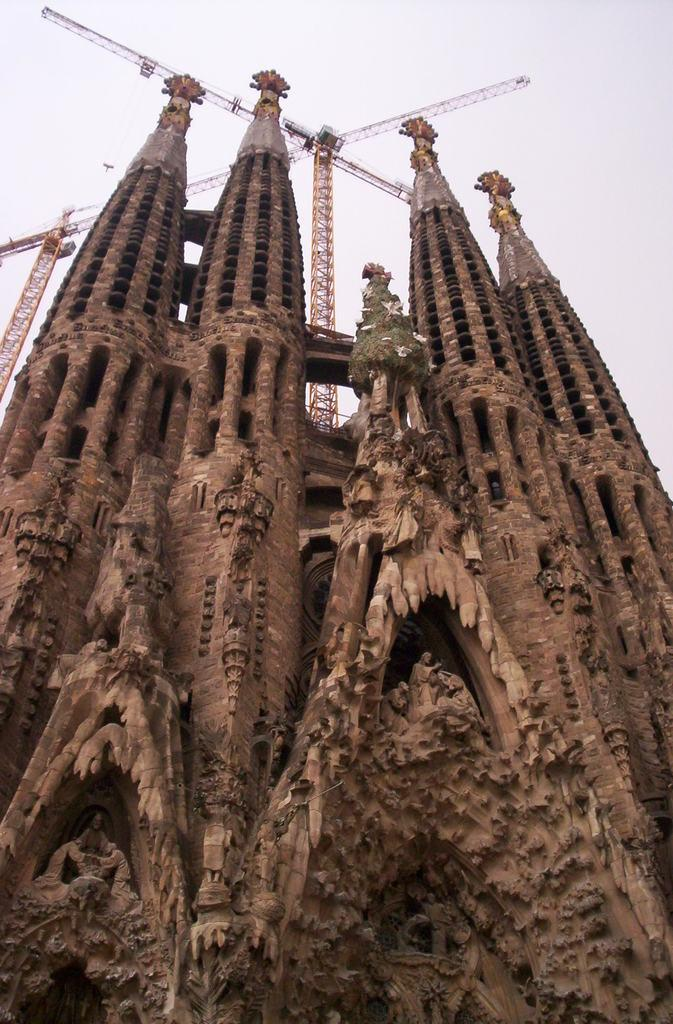What type of structure is present in the picture? There is a building in the picture. What specific features can be seen on the building? There are towers on the building. What else is visible in the picture besides the building? There are jobs, possibly referring to trees or other vegetation, in the picture. What can be seen in the background of the picture? The sky is visible in the background of the picture. What type of oatmeal is being served in the building in the picture? There is no indication of oatmeal or any food being served in the building in the picture. 